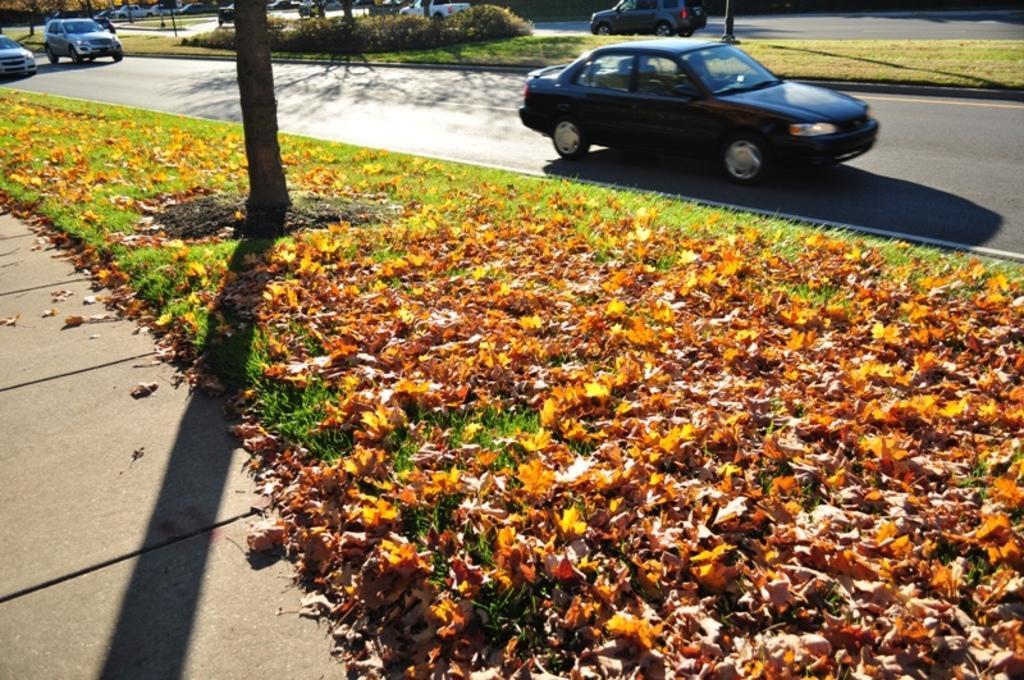Could you give a brief overview of what you see in this image? In this image we can see the flowers and the grass on the side of a road. Here we can see the cars on the road. 